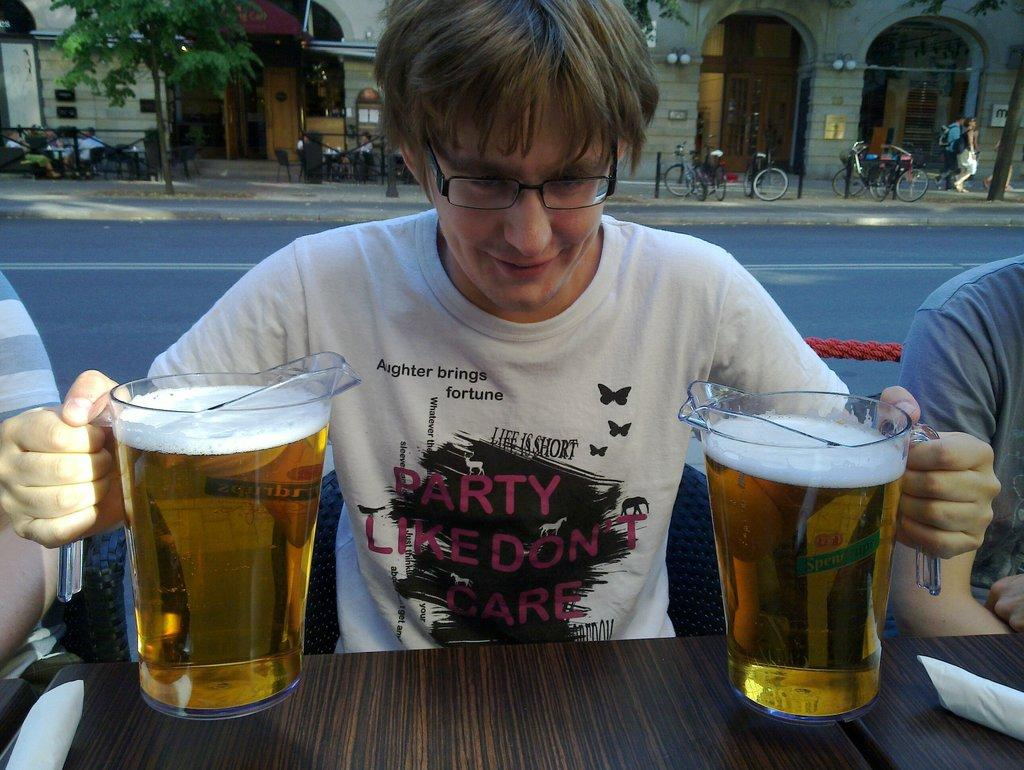Who is present in the image? There is a guy in the image. What is the guy holding in the image? The guy is holding two glasses of beer. Where are the glasses of beer located? The glasses of beer are on a table. What can be seen in the background of the image? There are bicycles, a building, and trees visible in the background of the image. What type of pancake is being served on the rail in the image? There is no pancake or rail present in the image. How is the guy tying a knot with the glasses of beer in the image? The guy is not tying a knot with the glasses of beer in the image; he is simply holding them. 